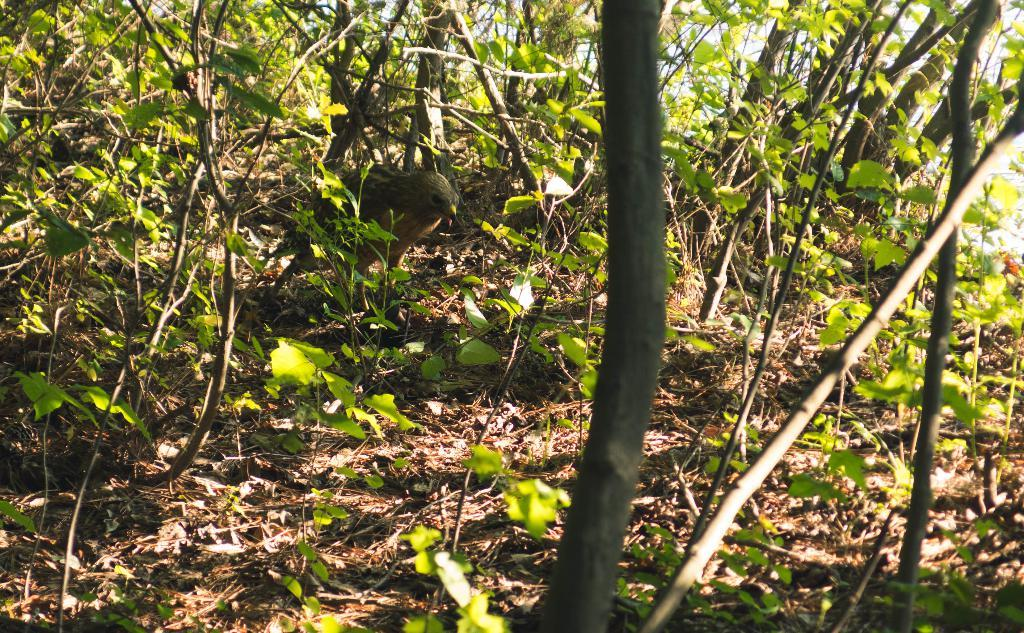What type of animal can be seen in the image? There is a bird in the image. What type of vegetation is present in the image? There are trees in the image. What else can be seen in the image besides the bird and trees? There are other objects in the image. What is visible in the background of the image? The sky is visible in the background of the image. What type of linen is used to create the bird in the image? There is no indication that the bird in the image is made of linen or any other fabric; it appears to be a real bird. 